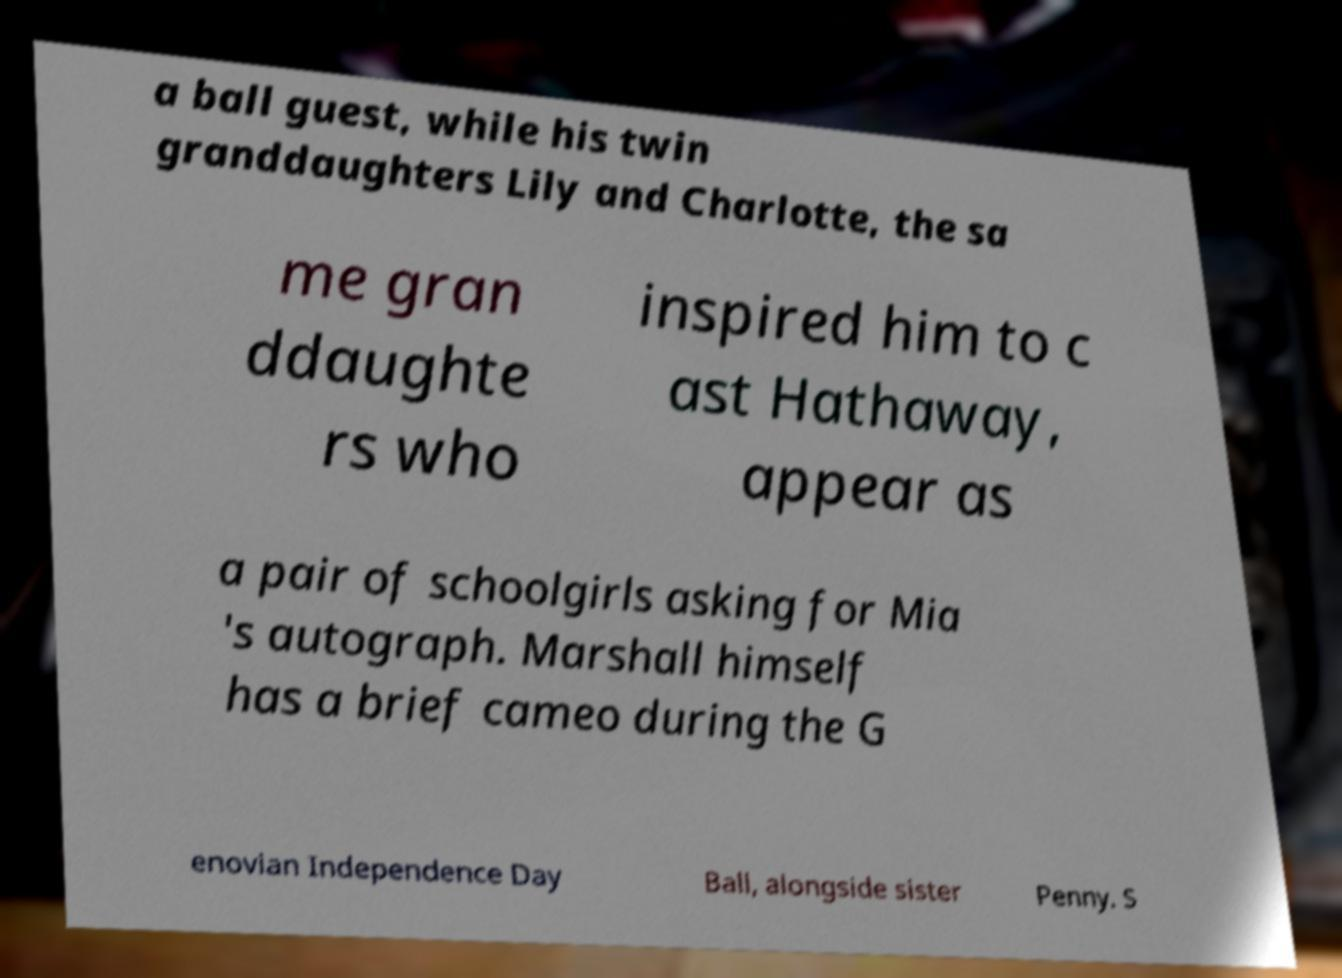Please identify and transcribe the text found in this image. a ball guest, while his twin granddaughters Lily and Charlotte, the sa me gran ddaughte rs who inspired him to c ast Hathaway, appear as a pair of schoolgirls asking for Mia 's autograph. Marshall himself has a brief cameo during the G enovian Independence Day Ball, alongside sister Penny. S 